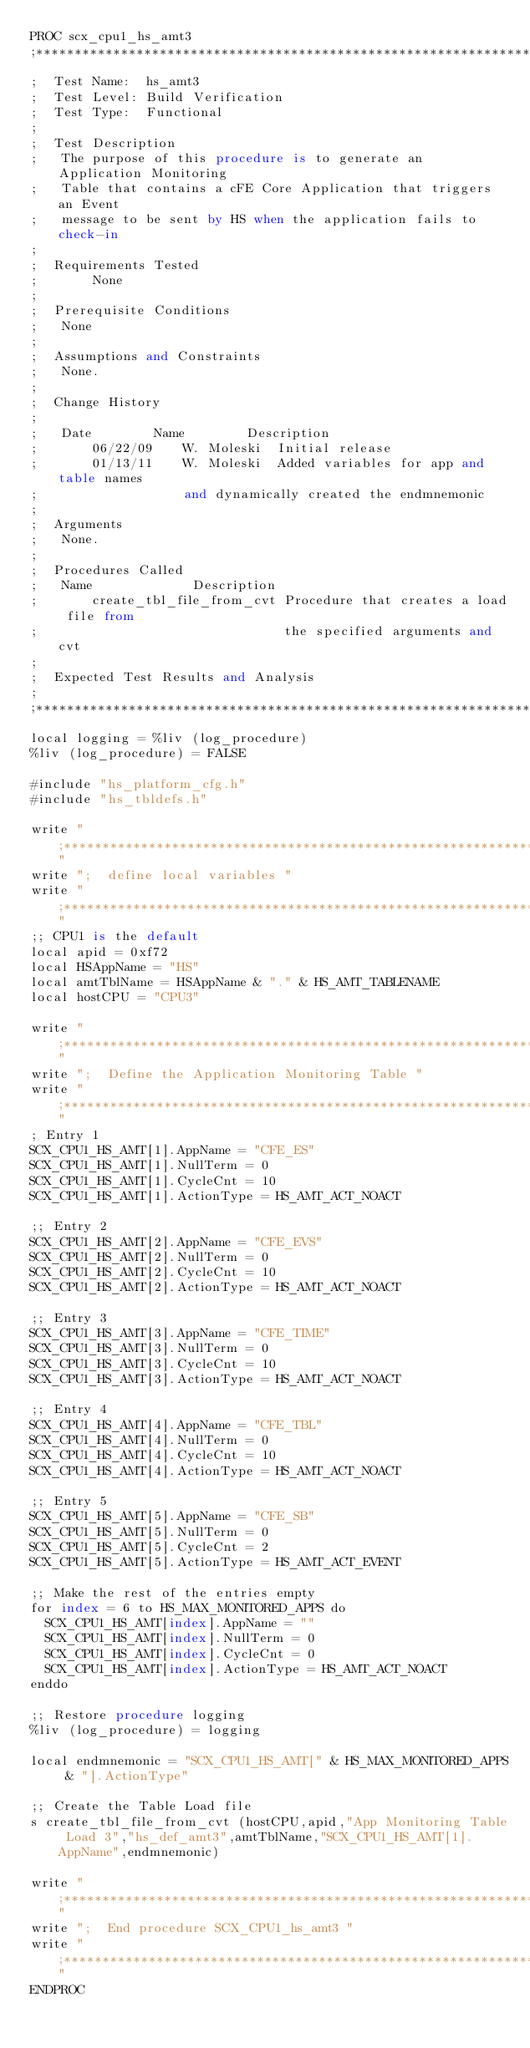Convert code to text. <code><loc_0><loc_0><loc_500><loc_500><_SQL_>PROC scx_cpu1_hs_amt3
;*******************************************************************************
;  Test Name:  hs_amt3
;  Test Level: Build Verification
;  Test Type:  Functional
;
;  Test Description
;	The purpose of this procedure is to generate an Application Monitoring
;	Table that contains a cFE Core Application that triggers an Event
;	message to be sent by HS when the application fails to check-in
;
;  Requirements Tested
;       None
;
;  Prerequisite Conditions
;	None
;
;  Assumptions and Constraints
;	None.
;
;  Change History
;
;	Date		Name		Description
;       06/22/09	W. Moleski	Initial release
;       01/13/11	W. Moleski	Added variables for app and table names
;					and dynamically created the endmnemonic
;
;  Arguments
;	None.
;
;  Procedures Called
;	Name			 Description
;       create_tbl_file_from_cvt Procedure that creates a load file from
;                                the specified arguments and cvt
;
;  Expected Test Results and Analysis
;
;**********************************************************************
local logging = %liv (log_procedure)
%liv (log_procedure) = FALSE

#include "hs_platform_cfg.h"
#include "hs_tbldefs.h"

write ";*********************************************************************"
write ";  define local variables "
write ";*********************************************************************"
;; CPU1 is the default
local apid = 0xf72
local HSAppName = "HS"
local amtTblName = HSAppName & "." & HS_AMT_TABLENAME
local hostCPU = "CPU3"

write ";*********************************************************************"
write ";  Define the Application Monitoring Table "
write ";*********************************************************************"
; Entry 1
SCX_CPU1_HS_AMT[1].AppName = "CFE_ES"
SCX_CPU1_HS_AMT[1].NullTerm = 0
SCX_CPU1_HS_AMT[1].CycleCnt = 10
SCX_CPU1_HS_AMT[1].ActionType = HS_AMT_ACT_NOACT

;; Entry 2
SCX_CPU1_HS_AMT[2].AppName = "CFE_EVS"
SCX_CPU1_HS_AMT[2].NullTerm = 0
SCX_CPU1_HS_AMT[2].CycleCnt = 10
SCX_CPU1_HS_AMT[2].ActionType = HS_AMT_ACT_NOACT

;; Entry 3
SCX_CPU1_HS_AMT[3].AppName = "CFE_TIME"
SCX_CPU1_HS_AMT[3].NullTerm = 0
SCX_CPU1_HS_AMT[3].CycleCnt = 10
SCX_CPU1_HS_AMT[3].ActionType = HS_AMT_ACT_NOACT

;; Entry 4
SCX_CPU1_HS_AMT[4].AppName = "CFE_TBL"
SCX_CPU1_HS_AMT[4].NullTerm = 0
SCX_CPU1_HS_AMT[4].CycleCnt = 10
SCX_CPU1_HS_AMT[4].ActionType = HS_AMT_ACT_NOACT

;; Entry 5
SCX_CPU1_HS_AMT[5].AppName = "CFE_SB"
SCX_CPU1_HS_AMT[5].NullTerm = 0
SCX_CPU1_HS_AMT[5].CycleCnt = 2
SCX_CPU1_HS_AMT[5].ActionType = HS_AMT_ACT_EVENT

;; Make the rest of the entries empty
for index = 6 to HS_MAX_MONITORED_APPS do
  SCX_CPU1_HS_AMT[index].AppName = ""
  SCX_CPU1_HS_AMT[index].NullTerm = 0
  SCX_CPU1_HS_AMT[index].CycleCnt = 0
  SCX_CPU1_HS_AMT[index].ActionType = HS_AMT_ACT_NOACT
enddo

;; Restore procedure logging
%liv (log_procedure) = logging

local endmnemonic = "SCX_CPU1_HS_AMT[" & HS_MAX_MONITORED_APPS & "].ActionType"

;; Create the Table Load file
s create_tbl_file_from_cvt (hostCPU,apid,"App Monitoring Table Load 3","hs_def_amt3",amtTblName,"SCX_CPU1_HS_AMT[1].AppName",endmnemonic)

write ";*********************************************************************"
write ";  End procedure SCX_CPU1_hs_amt3 "
write ";*********************************************************************"
ENDPROC
</code> 